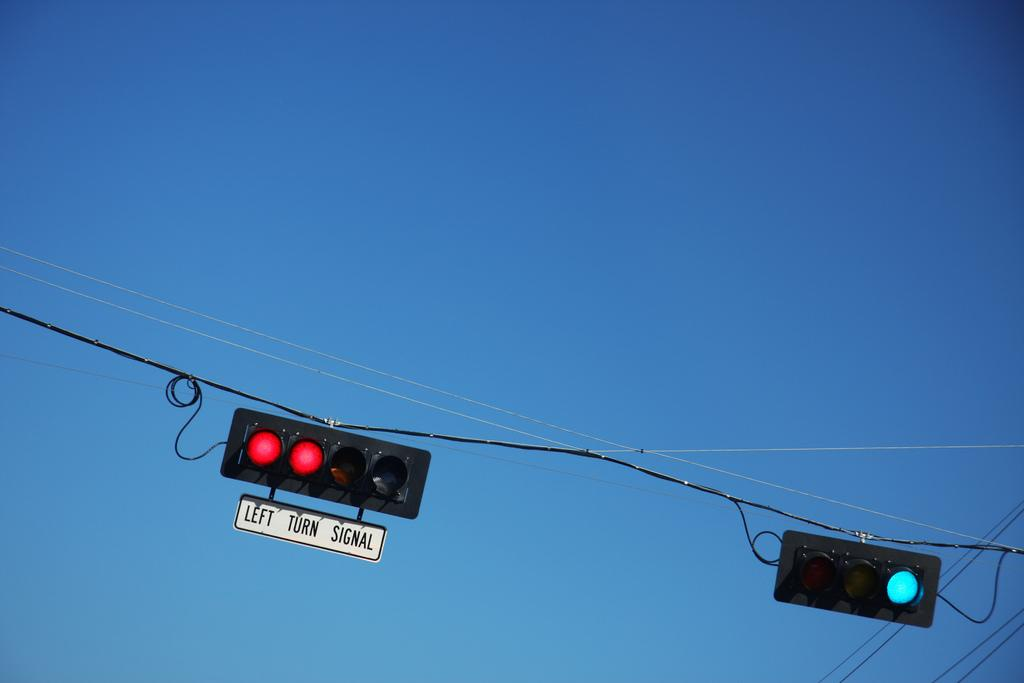<image>
Present a compact description of the photo's key features. A traffic light is hanging from a wire and a small white sign beneath it says Left Turn Signal. 